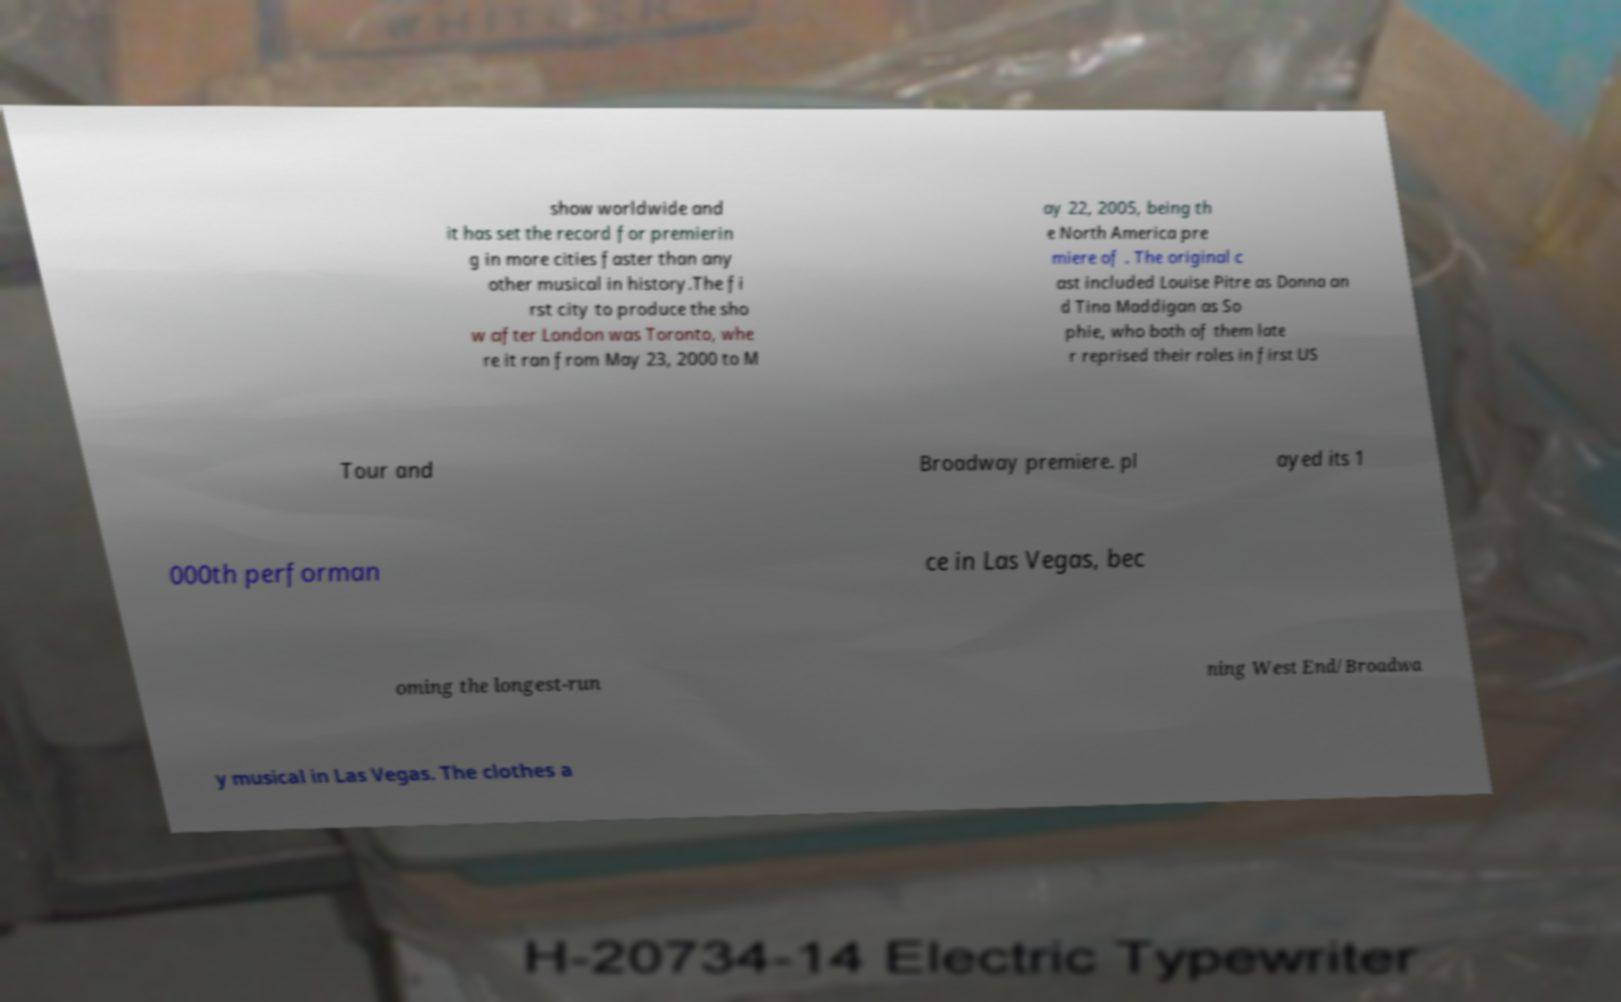For documentation purposes, I need the text within this image transcribed. Could you provide that? show worldwide and it has set the record for premierin g in more cities faster than any other musical in history.The fi rst city to produce the sho w after London was Toronto, whe re it ran from May 23, 2000 to M ay 22, 2005, being th e North America pre miere of . The original c ast included Louise Pitre as Donna an d Tina Maddigan as So phie, who both of them late r reprised their roles in first US Tour and Broadway premiere. pl ayed its 1 000th performan ce in Las Vegas, bec oming the longest-run ning West End/Broadwa y musical in Las Vegas. The clothes a 